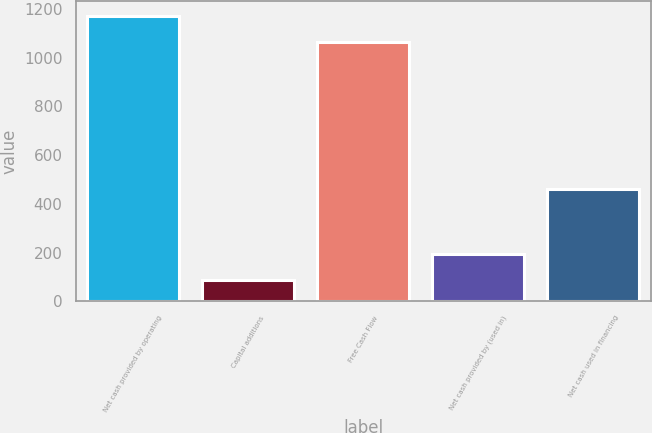<chart> <loc_0><loc_0><loc_500><loc_500><bar_chart><fcel>Net cash provided by operating<fcel>Capital additions<fcel>Free Cash Flow<fcel>Net cash provided by (used in)<fcel>Net cash used in financing<nl><fcel>1171.06<fcel>89<fcel>1064.6<fcel>195.46<fcel>461<nl></chart> 